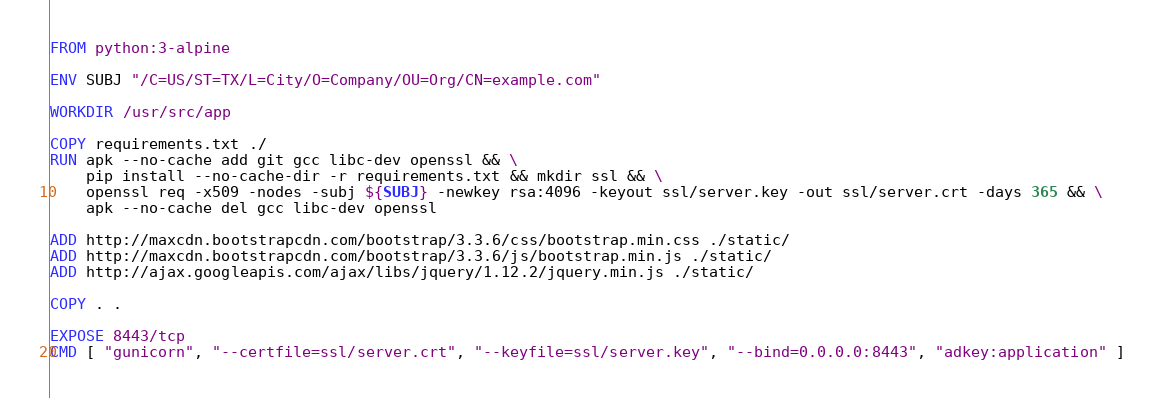<code> <loc_0><loc_0><loc_500><loc_500><_Dockerfile_>FROM python:3-alpine

ENV SUBJ "/C=US/ST=TX/L=City/O=Company/OU=Org/CN=example.com"

WORKDIR /usr/src/app

COPY requirements.txt ./
RUN apk --no-cache add git gcc libc-dev openssl && \
    pip install --no-cache-dir -r requirements.txt && mkdir ssl && \
    openssl req -x509 -nodes -subj ${SUBJ} -newkey rsa:4096 -keyout ssl/server.key -out ssl/server.crt -days 365 && \
    apk --no-cache del gcc libc-dev openssl

ADD http://maxcdn.bootstrapcdn.com/bootstrap/3.3.6/css/bootstrap.min.css ./static/
ADD http://maxcdn.bootstrapcdn.com/bootstrap/3.3.6/js/bootstrap.min.js ./static/
ADD http://ajax.googleapis.com/ajax/libs/jquery/1.12.2/jquery.min.js ./static/

COPY . .

EXPOSE 8443/tcp
CMD [ "gunicorn", "--certfile=ssl/server.crt", "--keyfile=ssl/server.key", "--bind=0.0.0.0:8443", "adkey:application" ]
</code> 